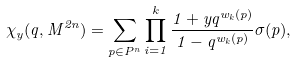<formula> <loc_0><loc_0><loc_500><loc_500>\chi _ { y } ( q , M ^ { 2 n } ) = \sum _ { p \in P ^ { n } } \prod _ { i = 1 } ^ { k } \frac { 1 + y q ^ { w _ { k } ( p ) } } { 1 - q ^ { w _ { k } ( p ) } } \sigma ( p ) ,</formula> 